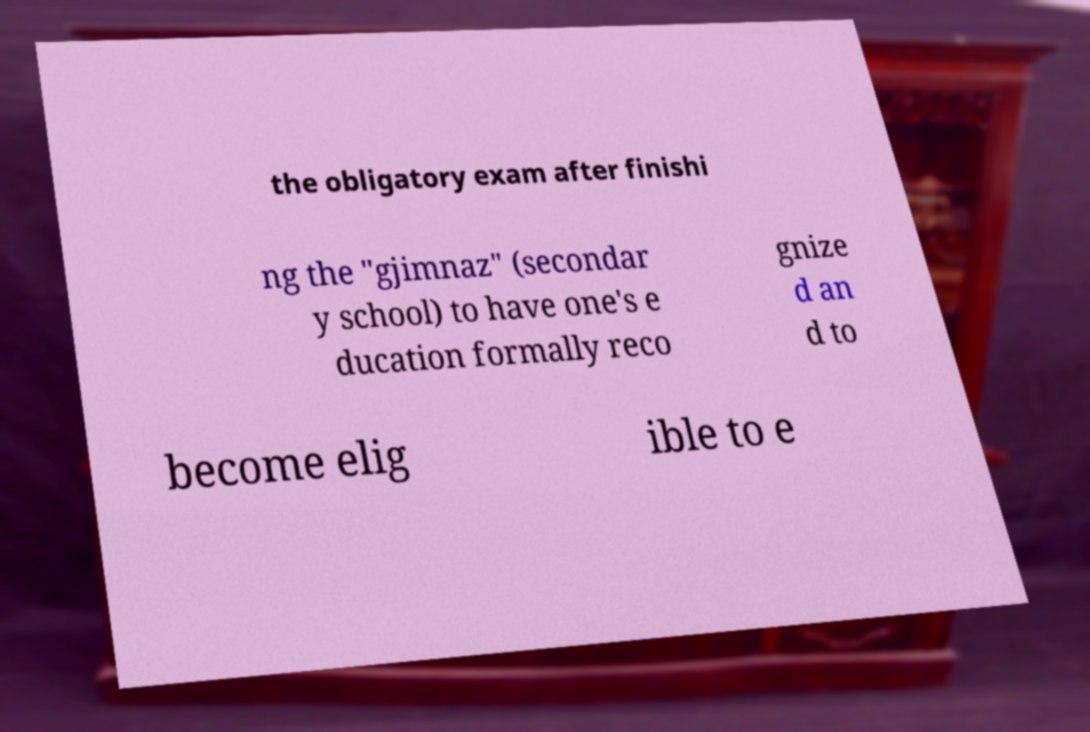Could you extract and type out the text from this image? the obligatory exam after finishi ng the "gjimnaz" (secondar y school) to have one's e ducation formally reco gnize d an d to become elig ible to e 